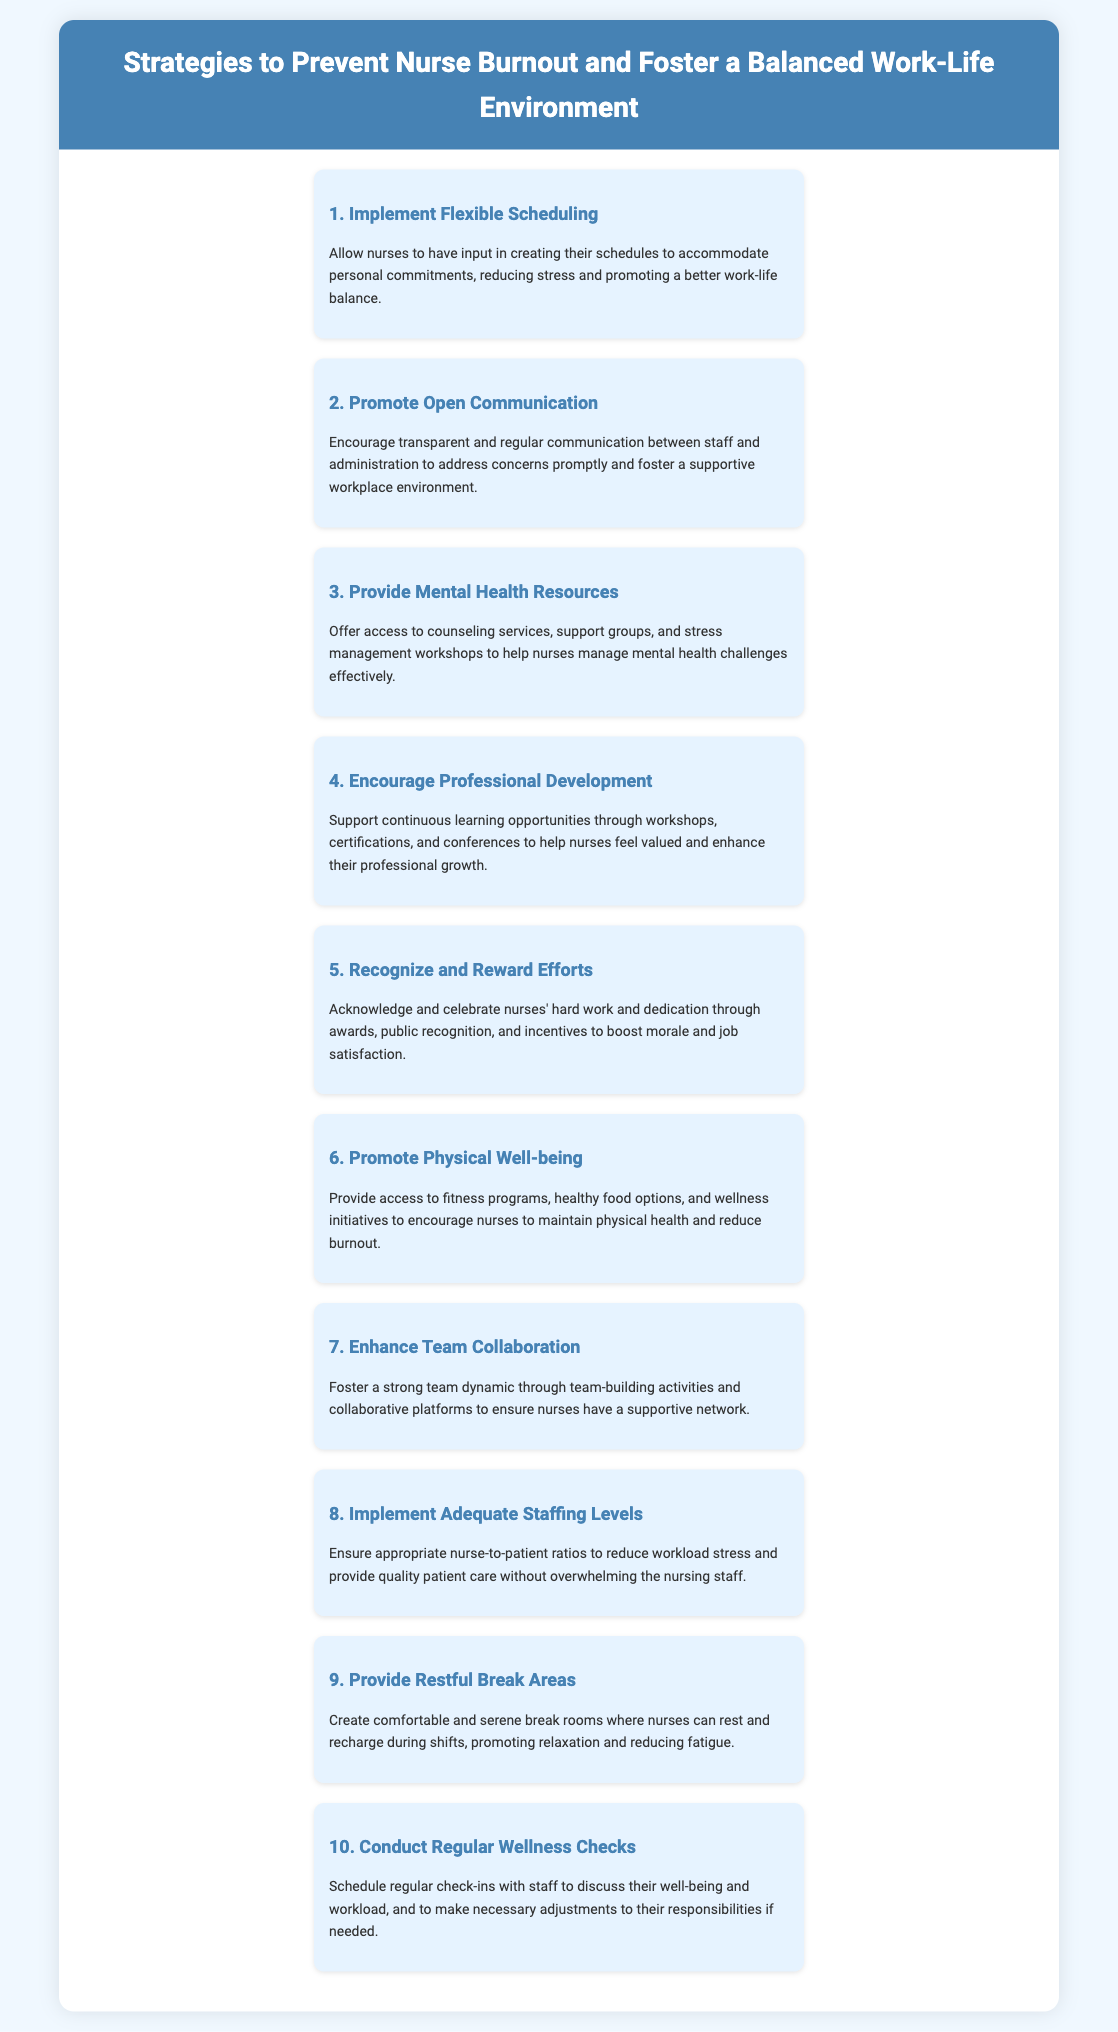What is the title of the infographic? The title is prominently displayed at the top of the document and is "Strategies to Prevent Nurse Burnout and Foster a Balanced Work-Life Environment."
Answer: Strategies to Prevent Nurse Burnout and Foster a Balanced Work-Life Environment How many strategies are listed in the document? The number of strategies is indicated by the list of items, which totals 10.
Answer: 10 Which strategy focuses on communication between staff and administration? The specific strategy for communication is titled "Promote Open Communication."
Answer: Promote Open Communication What is the purpose of providing mental health resources? The goal of offering mental health resources is to help nurses manage mental health challenges effectively.
Answer: Manage mental health challenges Which strategy emphasizes physical health for nurses? The strategy that emphasizes physical health is titled "Promote Physical Well-being."
Answer: Promote Physical Well-being What type of environment is created by providing restful break areas? Restful break areas are intended to create a comfortable and serene environment for nurses.
Answer: Comfortable and serene Which strategy aims to ensure appropriate nurse-to-patient ratios? The strategy related to staffing levels is titled "Implement Adequate Staffing Levels."
Answer: Implement Adequate Staffing Levels How does the infographic suggest recognizing nurses' efforts? Nurses' efforts are recognized through awards, public recognition, and incentives.
Answer: Awards, public recognition, and incentives 